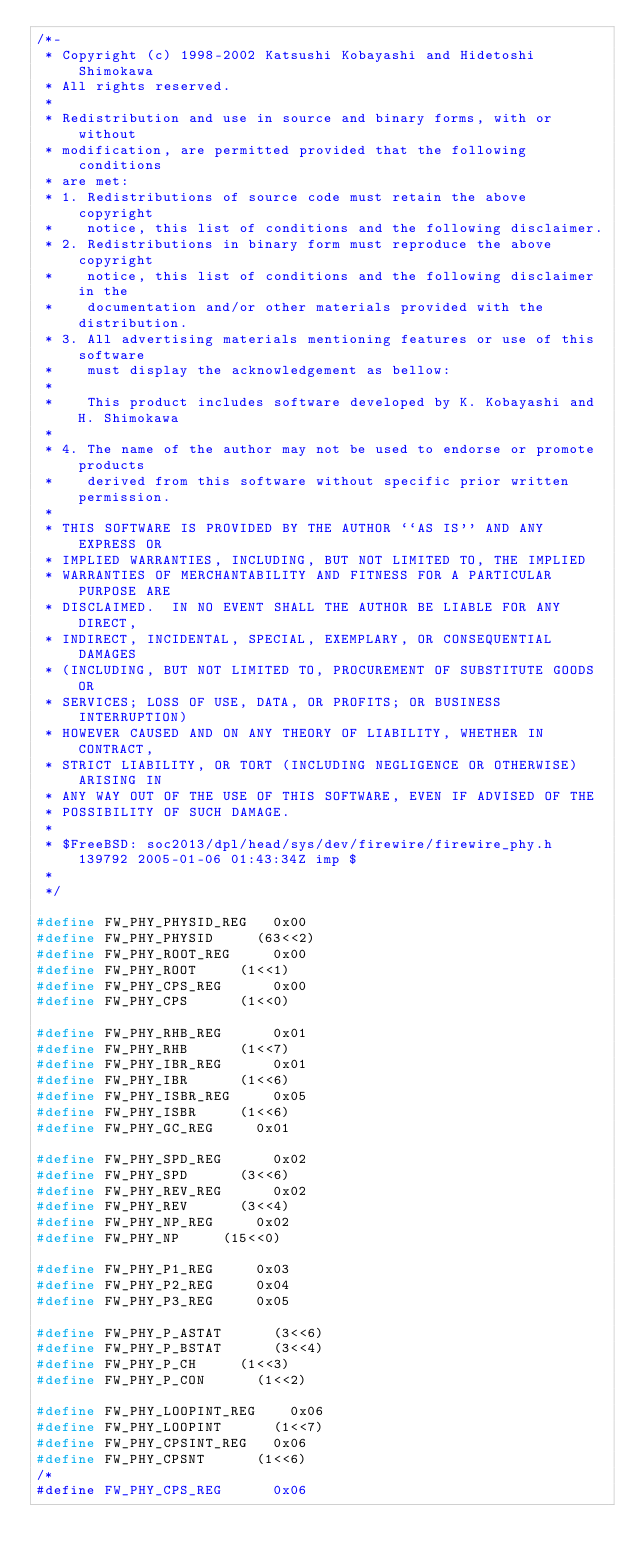<code> <loc_0><loc_0><loc_500><loc_500><_C_>/*-
 * Copyright (c) 1998-2002 Katsushi Kobayashi and Hidetoshi Shimokawa
 * All rights reserved.
 *
 * Redistribution and use in source and binary forms, with or without
 * modification, are permitted provided that the following conditions
 * are met:
 * 1. Redistributions of source code must retain the above copyright
 *    notice, this list of conditions and the following disclaimer.
 * 2. Redistributions in binary form must reproduce the above copyright
 *    notice, this list of conditions and the following disclaimer in the
 *    documentation and/or other materials provided with the distribution.
 * 3. All advertising materials mentioning features or use of this software
 *    must display the acknowledgement as bellow:
 *
 *    This product includes software developed by K. Kobayashi and H. Shimokawa
 *
 * 4. The name of the author may not be used to endorse or promote products
 *    derived from this software without specific prior written permission.
 *
 * THIS SOFTWARE IS PROVIDED BY THE AUTHOR ``AS IS'' AND ANY EXPRESS OR
 * IMPLIED WARRANTIES, INCLUDING, BUT NOT LIMITED TO, THE IMPLIED
 * WARRANTIES OF MERCHANTABILITY AND FITNESS FOR A PARTICULAR PURPOSE ARE
 * DISCLAIMED.  IN NO EVENT SHALL THE AUTHOR BE LIABLE FOR ANY DIRECT,
 * INDIRECT, INCIDENTAL, SPECIAL, EXEMPLARY, OR CONSEQUENTIAL DAMAGES
 * (INCLUDING, BUT NOT LIMITED TO, PROCUREMENT OF SUBSTITUTE GOODS OR
 * SERVICES; LOSS OF USE, DATA, OR PROFITS; OR BUSINESS INTERRUPTION)
 * HOWEVER CAUSED AND ON ANY THEORY OF LIABILITY, WHETHER IN CONTRACT,
 * STRICT LIABILITY, OR TORT (INCLUDING NEGLIGENCE OR OTHERWISE) ARISING IN
 * ANY WAY OUT OF THE USE OF THIS SOFTWARE, EVEN IF ADVISED OF THE
 * POSSIBILITY OF SUCH DAMAGE.
 * 
 * $FreeBSD: soc2013/dpl/head/sys/dev/firewire/firewire_phy.h 139792 2005-01-06 01:43:34Z imp $
 *
 */

#define	FW_PHY_PHYSID_REG		0x00
#define	FW_PHY_PHYSID			(63<<2)
#define	FW_PHY_ROOT_REG			0x00
#define	FW_PHY_ROOT			(1<<1)
#define	FW_PHY_CPS_REG			0x00
#define	FW_PHY_CPS			(1<<0)

#define	FW_PHY_RHB_REG			0x01
#define	FW_PHY_RHB			(1<<7)
#define	FW_PHY_IBR_REG			0x01
#define	FW_PHY_IBR			(1<<6)
#define	FW_PHY_ISBR_REG			0x05
#define	FW_PHY_ISBR			(1<<6)
#define	FW_PHY_GC_REG			0x01

#define	FW_PHY_SPD_REG			0x02
#define	FW_PHY_SPD			(3<<6)
#define	FW_PHY_REV_REG			0x02
#define	FW_PHY_REV			(3<<4)
#define	FW_PHY_NP_REG			0x02
#define	FW_PHY_NP			(15<<0)

#define	FW_PHY_P1_REG			0x03
#define	FW_PHY_P2_REG			0x04
#define	FW_PHY_P3_REG			0x05

#define	FW_PHY_P_ASTAT			(3<<6)
#define	FW_PHY_P_BSTAT			(3<<4)
#define	FW_PHY_P_CH			(1<<3)
#define	FW_PHY_P_CON			(1<<2)

#define FW_PHY_LOOPINT_REG		0x06
#define FW_PHY_LOOPINT			(1<<7)
#define FW_PHY_CPSINT_REG		0x06
#define FW_PHY_CPSNT			(1<<6)
/*
#define FW_PHY_CPS_REG			0x06</code> 